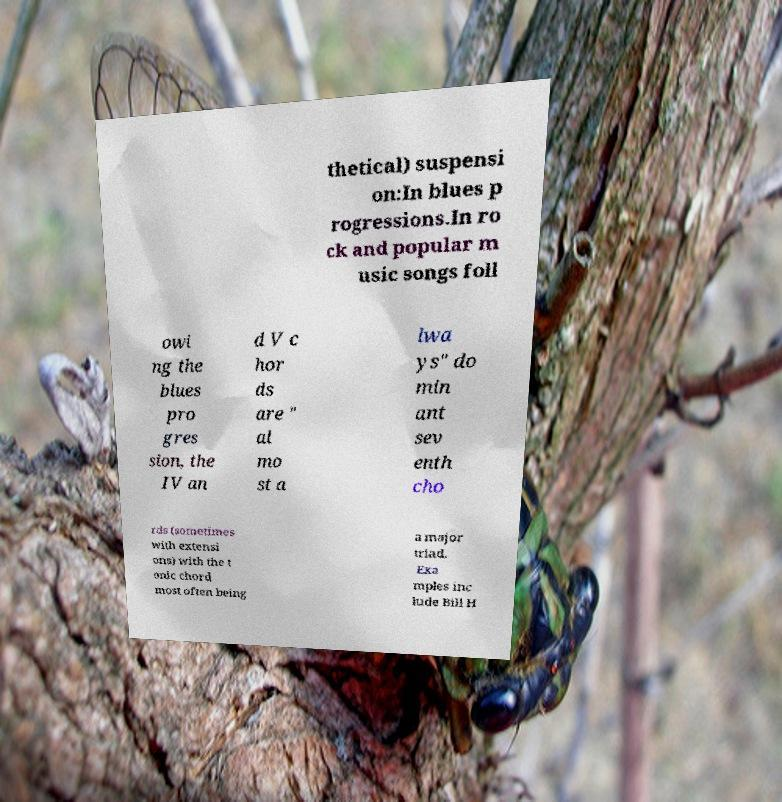For documentation purposes, I need the text within this image transcribed. Could you provide that? thetical) suspensi on:In blues p rogressions.In ro ck and popular m usic songs foll owi ng the blues pro gres sion, the IV an d V c hor ds are " al mo st a lwa ys" do min ant sev enth cho rds (sometimes with extensi ons) with the t onic chord most often being a major triad. Exa mples inc lude Bill H 